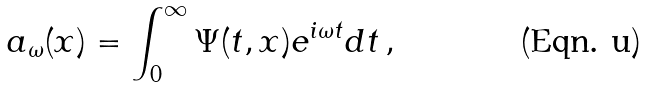<formula> <loc_0><loc_0><loc_500><loc_500>a _ { \omega } ( { x } ) = \int _ { 0 } ^ { \infty } \Psi ( t , { x } ) e ^ { i \omega t } d t \, ,</formula> 